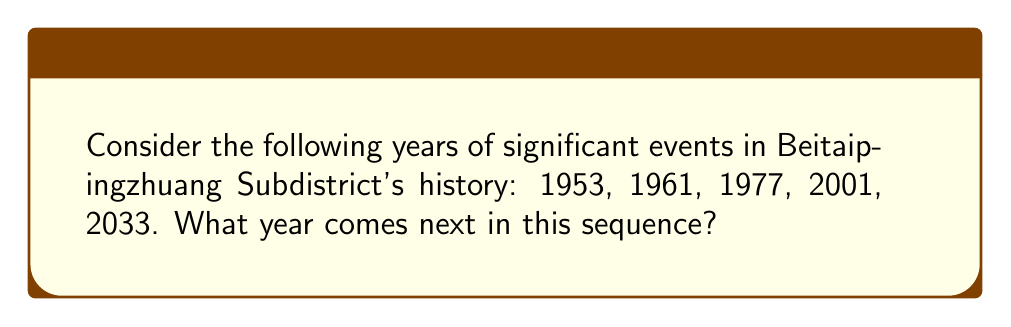Provide a solution to this math problem. To find the pattern in this sequence, we need to calculate the differences between consecutive terms:

1. $1961 - 1953 = 8$
2. $1977 - 1961 = 16$
3. $2001 - 1977 = 24$
4. $2033 - 2001 = 32$

We can observe that the differences form an arithmetic sequence with a common difference of 8:

$8, 16, 24, 32$

This suggests that the next difference in the sequence would be:

$32 + 8 = 40$

Therefore, to find the next year in the sequence, we add 40 to the last given year:

$2033 + 40 = 2073$

Thus, the next year in the sequence is 2073.
Answer: 2073 